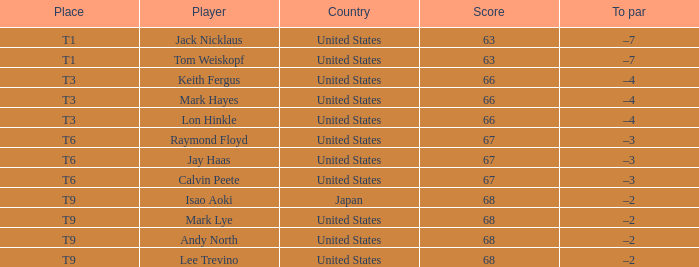What is the location when the country is "united states" and the player is "lee trevino"? T9. 